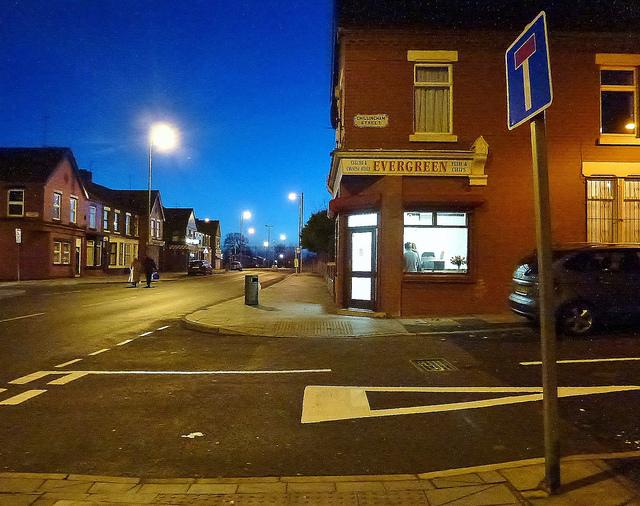Are the street lights on?
Concise answer only. Yes. How many people are in the middle of the street?
Give a very brief answer. 2. What time is it?
Give a very brief answer. Night. How many light poles in the picture?
Keep it brief. 6. Is this a residential area?
Give a very brief answer. Yes. Is there any street work going on?
Quick response, please. No. Is this picture taken in the daytime?
Keep it brief. No. What color is the sign?
Write a very short answer. Blue. What symbol is on the closest sign?
Give a very brief answer. T. Is this a small town?
Keep it brief. Yes. What color are the markings on the street?
Be succinct. White. Is there a statue in the photo?
Answer briefly. No. 